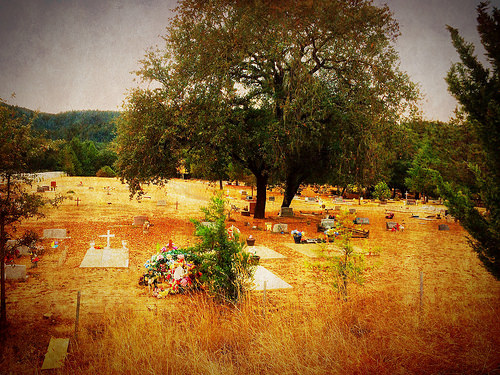<image>
Can you confirm if the gravestone is under the tree? Yes. The gravestone is positioned underneath the tree, with the tree above it in the vertical space. 